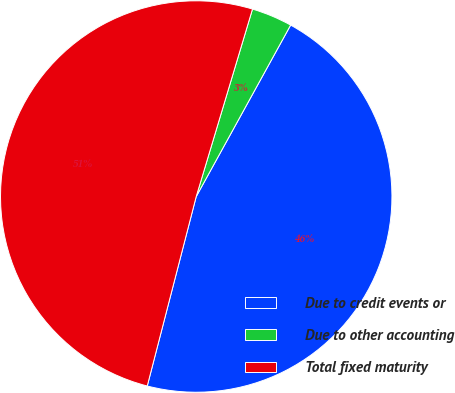<chart> <loc_0><loc_0><loc_500><loc_500><pie_chart><fcel>Due to credit events or<fcel>Due to other accounting<fcel>Total fixed maturity<nl><fcel>46.02%<fcel>3.37%<fcel>50.62%<nl></chart> 